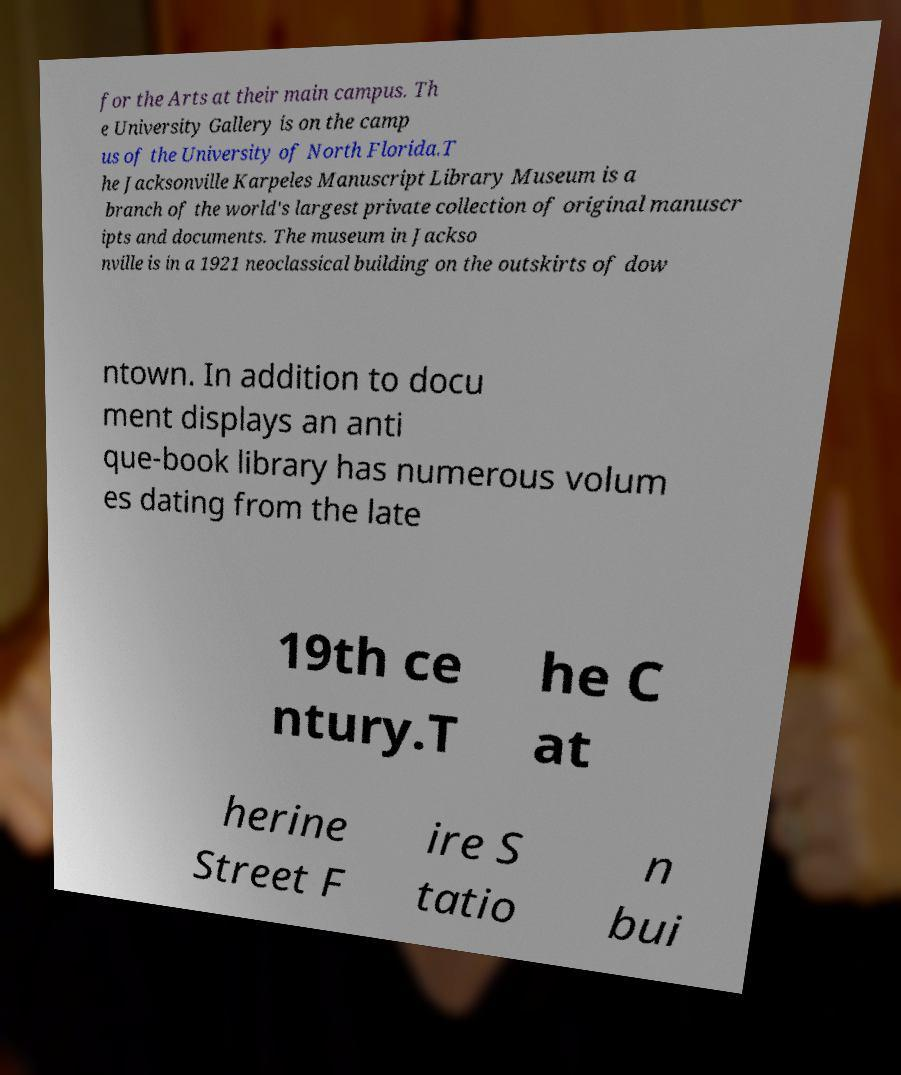Can you accurately transcribe the text from the provided image for me? for the Arts at their main campus. Th e University Gallery is on the camp us of the University of North Florida.T he Jacksonville Karpeles Manuscript Library Museum is a branch of the world's largest private collection of original manuscr ipts and documents. The museum in Jackso nville is in a 1921 neoclassical building on the outskirts of dow ntown. In addition to docu ment displays an anti que-book library has numerous volum es dating from the late 19th ce ntury.T he C at herine Street F ire S tatio n bui 